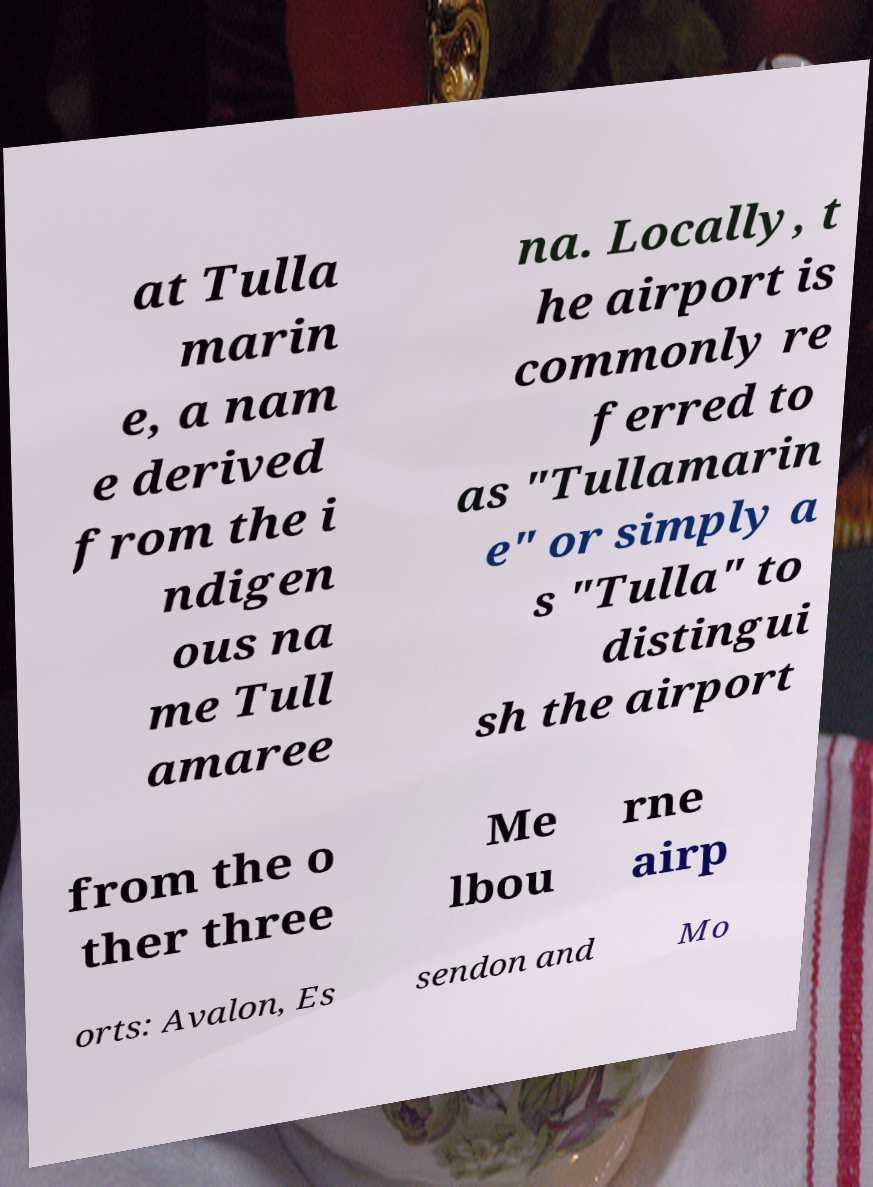I need the written content from this picture converted into text. Can you do that? at Tulla marin e, a nam e derived from the i ndigen ous na me Tull amaree na. Locally, t he airport is commonly re ferred to as "Tullamarin e" or simply a s "Tulla" to distingui sh the airport from the o ther three Me lbou rne airp orts: Avalon, Es sendon and Mo 